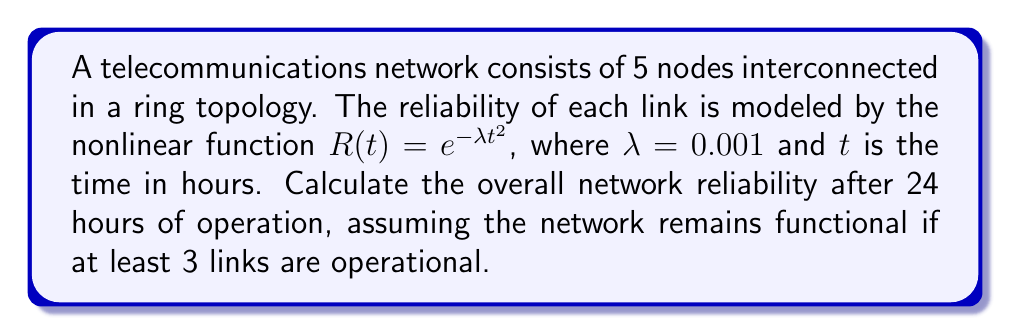Teach me how to tackle this problem. To solve this problem, we'll follow these steps:

1) First, we need to calculate the reliability of a single link after 24 hours:
   $R(24) = e^{-0.001 * 24^2} = e^{-0.576} \approx 0.5623$

2) The probability of a link failing is:
   $P(\text{failure}) = 1 - R(24) \approx 0.4377$

3) Now, we need to calculate the probability of at least 3 links being operational. This is equivalent to the probability of 3, 4, or 5 links being operational.

4) We can use the binomial probability formula:
   $P(X=k) = \binom{n}{k} p^k (1-p)^{n-k}$
   where $n=5$ (total links), $k$ is the number of operational links, and $p=0.5623$ (probability of a link being operational)

5) Calculate probabilities:
   $P(5\text{ operational}) = \binom{5}{5} 0.5623^5 \approx 0.0540$
   $P(4\text{ operational}) = \binom{5}{4} 0.5623^4 (0.4377) \approx 0.2115$
   $P(3\text{ operational}) = \binom{5}{3} 0.5623^3 (0.4377)^2 \approx 0.3307$

6) Sum these probabilities:
   $P(\text{at least 3 operational}) = 0.0540 + 0.2115 + 0.3307 = 0.5962$

Therefore, the overall network reliability after 24 hours is approximately 0.5962 or 59.62%.
Answer: 0.5962 